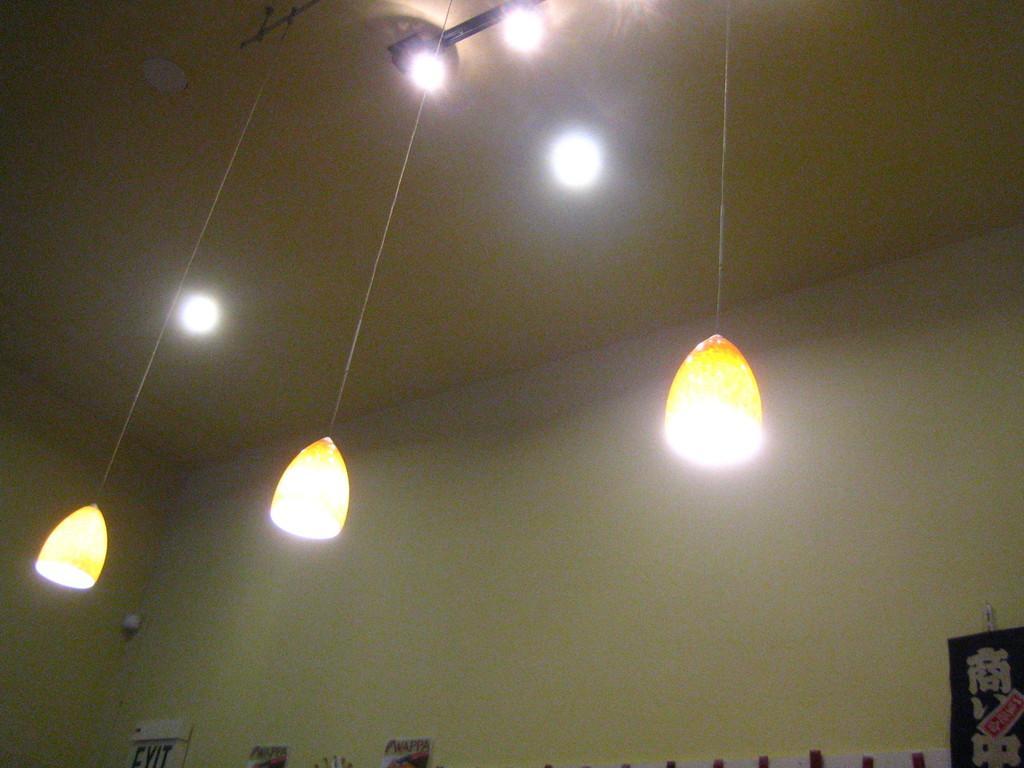Please provide a concise description of this image. In this image there are lights which are hanged to the roof. At the bottom there is a exit board on the left side. There is a poster which is sticked to the wall. At the top there are lights. 